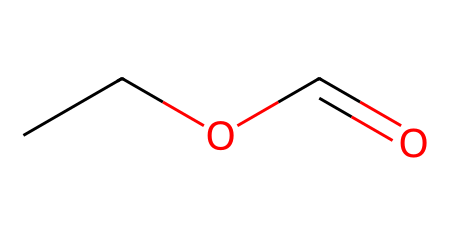What is the name of this ester? The structure provided corresponds to ethyl formate, which is an ester derived from formic acid and ethanol. This can be confirmed by recognizing the -O- and the carbonyl group (C=O) characteristic of esters, along with the ethyl (C2H5) group.
Answer: ethyl formate How many different types of atoms are present in ethyl formate? In the chemical structure of ethyl formate, it includes carbon (C), hydrogen (H), and oxygen (O). By counting the unique elements represented, we find three different types of atoms.
Answer: three What is the total number of carbon atoms in this molecule? By analyzing the SMILES representation, "CCOC=O," we see there are two carbon atoms from the ethyl group (CC) and one from the carbonyl group (C=O), resulting in a total of three carbon atoms.
Answer: three Which functional group is present in ethyl formate that characterizes it as an ester? The presence of the carbonyl group (C=O) bonded to an oxygen atom (O) that is also attached to another carbon (from the ethyl group) identifies this functional group as an ester. This specific arrangement is characteristic of esters.
Answer: ester What is the relationship between ethyl formate and formic acid? Ethyl formate is the ester formed by the reaction of formic acid and ethanol. In the esterification process, the hydroxyl group (-OH) of the carboxylic acid (formic acid) is replaced by an ethyl group from the alcohol (ethanol), resulting in the formation of ethyl formate.
Answer: esterification 